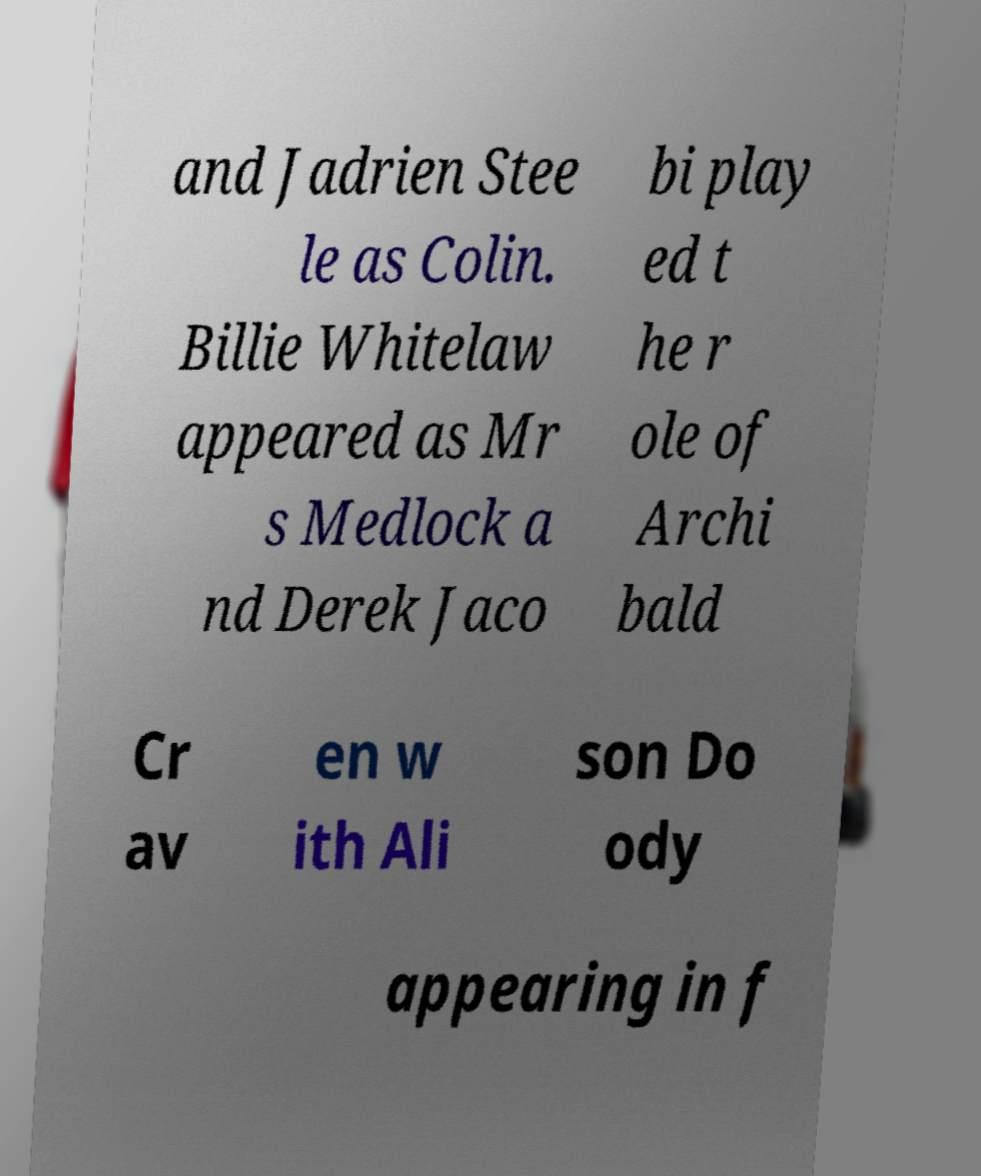Please read and relay the text visible in this image. What does it say? and Jadrien Stee le as Colin. Billie Whitelaw appeared as Mr s Medlock a nd Derek Jaco bi play ed t he r ole of Archi bald Cr av en w ith Ali son Do ody appearing in f 